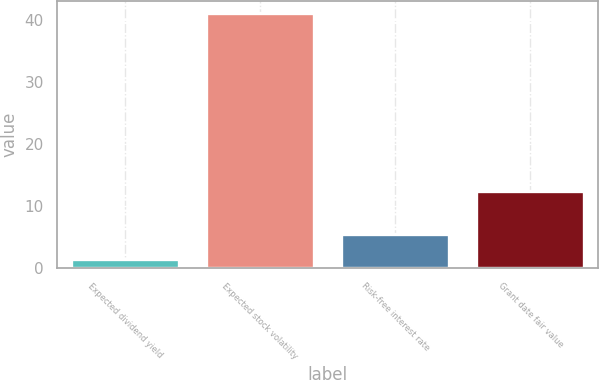Convert chart. <chart><loc_0><loc_0><loc_500><loc_500><bar_chart><fcel>Expected dividend yield<fcel>Expected stock volatility<fcel>Risk-free interest rate<fcel>Grant date fair value<nl><fcel>1.53<fcel>41<fcel>5.48<fcel>12.49<nl></chart> 